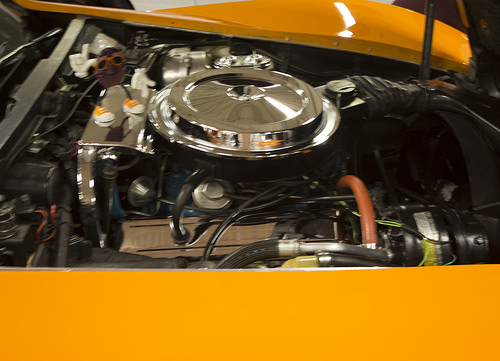<image>
Is there a cable under the disc? Yes. The cable is positioned underneath the disc, with the disc above it in the vertical space. 